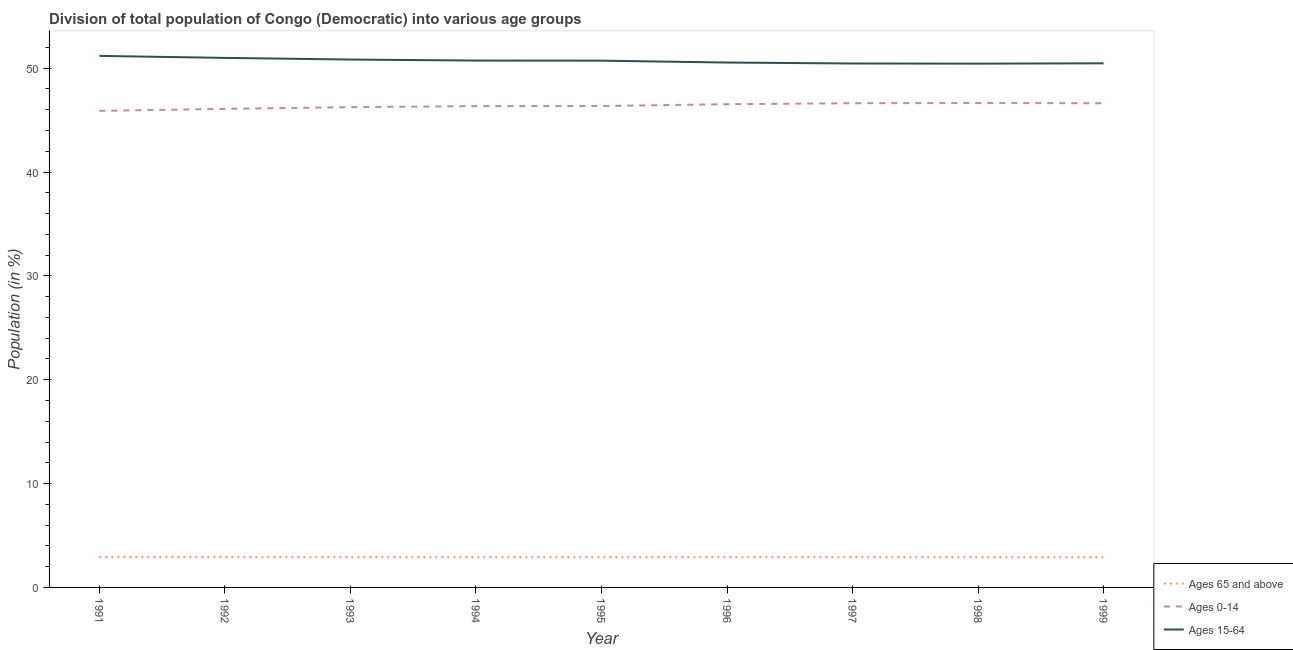How many different coloured lines are there?
Your answer should be very brief. 3. What is the percentage of population within the age-group 0-14 in 1996?
Your answer should be compact. 46.54. Across all years, what is the maximum percentage of population within the age-group of 65 and above?
Your response must be concise. 2.92. Across all years, what is the minimum percentage of population within the age-group 0-14?
Offer a terse response. 45.89. In which year was the percentage of population within the age-group 0-14 maximum?
Offer a terse response. 1998. What is the total percentage of population within the age-group of 65 and above in the graph?
Ensure brevity in your answer.  26.21. What is the difference between the percentage of population within the age-group 0-14 in 1991 and that in 1996?
Ensure brevity in your answer.  -0.64. What is the difference between the percentage of population within the age-group 15-64 in 1992 and the percentage of population within the age-group 0-14 in 1996?
Make the answer very short. 4.46. What is the average percentage of population within the age-group of 65 and above per year?
Keep it short and to the point. 2.91. In the year 1995, what is the difference between the percentage of population within the age-group 0-14 and percentage of population within the age-group of 65 and above?
Offer a terse response. 43.45. What is the ratio of the percentage of population within the age-group 0-14 in 1996 to that in 1998?
Provide a short and direct response. 1. Is the difference between the percentage of population within the age-group of 65 and above in 1991 and 1992 greater than the difference between the percentage of population within the age-group 0-14 in 1991 and 1992?
Your response must be concise. Yes. What is the difference between the highest and the second highest percentage of population within the age-group 15-64?
Your response must be concise. 0.19. What is the difference between the highest and the lowest percentage of population within the age-group of 65 and above?
Make the answer very short. 0.02. Does the percentage of population within the age-group 15-64 monotonically increase over the years?
Your answer should be compact. No. Is the percentage of population within the age-group 15-64 strictly less than the percentage of population within the age-group of 65 and above over the years?
Make the answer very short. No. How many years are there in the graph?
Ensure brevity in your answer.  9. What is the difference between two consecutive major ticks on the Y-axis?
Your answer should be compact. 10. Where does the legend appear in the graph?
Provide a short and direct response. Bottom right. How many legend labels are there?
Offer a very short reply. 3. What is the title of the graph?
Offer a terse response. Division of total population of Congo (Democratic) into various age groups
. What is the label or title of the Y-axis?
Offer a very short reply. Population (in %). What is the Population (in %) of Ages 65 and above in 1991?
Ensure brevity in your answer.  2.92. What is the Population (in %) in Ages 0-14 in 1991?
Ensure brevity in your answer.  45.89. What is the Population (in %) in Ages 15-64 in 1991?
Offer a terse response. 51.19. What is the Population (in %) of Ages 65 and above in 1992?
Offer a terse response. 2.92. What is the Population (in %) of Ages 0-14 in 1992?
Offer a very short reply. 46.09. What is the Population (in %) of Ages 15-64 in 1992?
Your response must be concise. 50.99. What is the Population (in %) of Ages 65 and above in 1993?
Offer a very short reply. 2.91. What is the Population (in %) in Ages 0-14 in 1993?
Your response must be concise. 46.25. What is the Population (in %) in Ages 15-64 in 1993?
Your answer should be compact. 50.84. What is the Population (in %) in Ages 65 and above in 1994?
Your answer should be very brief. 2.91. What is the Population (in %) of Ages 0-14 in 1994?
Your answer should be compact. 46.35. What is the Population (in %) in Ages 15-64 in 1994?
Your answer should be compact. 50.74. What is the Population (in %) of Ages 65 and above in 1995?
Offer a terse response. 2.91. What is the Population (in %) in Ages 0-14 in 1995?
Your answer should be very brief. 46.36. What is the Population (in %) in Ages 15-64 in 1995?
Offer a very short reply. 50.73. What is the Population (in %) in Ages 65 and above in 1996?
Provide a succinct answer. 2.92. What is the Population (in %) of Ages 0-14 in 1996?
Your answer should be very brief. 46.54. What is the Population (in %) in Ages 15-64 in 1996?
Offer a terse response. 50.55. What is the Population (in %) of Ages 65 and above in 1997?
Your response must be concise. 2.91. What is the Population (in %) in Ages 0-14 in 1997?
Give a very brief answer. 46.63. What is the Population (in %) of Ages 15-64 in 1997?
Provide a short and direct response. 50.46. What is the Population (in %) in Ages 65 and above in 1998?
Your response must be concise. 2.91. What is the Population (in %) of Ages 0-14 in 1998?
Provide a succinct answer. 46.65. What is the Population (in %) in Ages 15-64 in 1998?
Offer a terse response. 50.44. What is the Population (in %) of Ages 65 and above in 1999?
Offer a very short reply. 2.9. What is the Population (in %) in Ages 0-14 in 1999?
Give a very brief answer. 46.63. What is the Population (in %) of Ages 15-64 in 1999?
Provide a short and direct response. 50.47. Across all years, what is the maximum Population (in %) of Ages 65 and above?
Offer a very short reply. 2.92. Across all years, what is the maximum Population (in %) of Ages 0-14?
Make the answer very short. 46.65. Across all years, what is the maximum Population (in %) in Ages 15-64?
Provide a succinct answer. 51.19. Across all years, what is the minimum Population (in %) in Ages 65 and above?
Your response must be concise. 2.9. Across all years, what is the minimum Population (in %) in Ages 0-14?
Your answer should be compact. 45.89. Across all years, what is the minimum Population (in %) of Ages 15-64?
Keep it short and to the point. 50.44. What is the total Population (in %) of Ages 65 and above in the graph?
Your answer should be compact. 26.21. What is the total Population (in %) in Ages 0-14 in the graph?
Offer a terse response. 417.38. What is the total Population (in %) in Ages 15-64 in the graph?
Give a very brief answer. 456.4. What is the difference between the Population (in %) in Ages 65 and above in 1991 and that in 1992?
Offer a very short reply. 0. What is the difference between the Population (in %) in Ages 0-14 in 1991 and that in 1992?
Provide a short and direct response. -0.19. What is the difference between the Population (in %) of Ages 15-64 in 1991 and that in 1992?
Your answer should be compact. 0.19. What is the difference between the Population (in %) of Ages 65 and above in 1991 and that in 1993?
Your answer should be compact. 0. What is the difference between the Population (in %) in Ages 0-14 in 1991 and that in 1993?
Make the answer very short. -0.35. What is the difference between the Population (in %) of Ages 15-64 in 1991 and that in 1993?
Provide a succinct answer. 0.35. What is the difference between the Population (in %) of Ages 65 and above in 1991 and that in 1994?
Offer a very short reply. 0.01. What is the difference between the Population (in %) of Ages 0-14 in 1991 and that in 1994?
Make the answer very short. -0.46. What is the difference between the Population (in %) of Ages 15-64 in 1991 and that in 1994?
Provide a short and direct response. 0.45. What is the difference between the Population (in %) of Ages 65 and above in 1991 and that in 1995?
Ensure brevity in your answer.  0.01. What is the difference between the Population (in %) in Ages 0-14 in 1991 and that in 1995?
Provide a succinct answer. -0.47. What is the difference between the Population (in %) of Ages 15-64 in 1991 and that in 1995?
Keep it short and to the point. 0.46. What is the difference between the Population (in %) in Ages 65 and above in 1991 and that in 1996?
Ensure brevity in your answer.  0. What is the difference between the Population (in %) of Ages 0-14 in 1991 and that in 1996?
Keep it short and to the point. -0.64. What is the difference between the Population (in %) in Ages 15-64 in 1991 and that in 1996?
Provide a succinct answer. 0.64. What is the difference between the Population (in %) in Ages 65 and above in 1991 and that in 1997?
Give a very brief answer. 0. What is the difference between the Population (in %) of Ages 0-14 in 1991 and that in 1997?
Your answer should be compact. -0.73. What is the difference between the Population (in %) of Ages 15-64 in 1991 and that in 1997?
Provide a short and direct response. 0.73. What is the difference between the Population (in %) in Ages 65 and above in 1991 and that in 1998?
Your response must be concise. 0.01. What is the difference between the Population (in %) in Ages 0-14 in 1991 and that in 1998?
Provide a short and direct response. -0.75. What is the difference between the Population (in %) in Ages 15-64 in 1991 and that in 1998?
Provide a succinct answer. 0.75. What is the difference between the Population (in %) in Ages 65 and above in 1991 and that in 1999?
Your answer should be very brief. 0.02. What is the difference between the Population (in %) of Ages 0-14 in 1991 and that in 1999?
Provide a succinct answer. -0.73. What is the difference between the Population (in %) in Ages 15-64 in 1991 and that in 1999?
Offer a terse response. 0.71. What is the difference between the Population (in %) in Ages 65 and above in 1992 and that in 1993?
Ensure brevity in your answer.  0. What is the difference between the Population (in %) of Ages 0-14 in 1992 and that in 1993?
Provide a short and direct response. -0.16. What is the difference between the Population (in %) in Ages 15-64 in 1992 and that in 1993?
Offer a terse response. 0.16. What is the difference between the Population (in %) in Ages 65 and above in 1992 and that in 1994?
Your response must be concise. 0.01. What is the difference between the Population (in %) of Ages 0-14 in 1992 and that in 1994?
Your answer should be very brief. -0.26. What is the difference between the Population (in %) of Ages 15-64 in 1992 and that in 1994?
Give a very brief answer. 0.26. What is the difference between the Population (in %) in Ages 65 and above in 1992 and that in 1995?
Offer a very short reply. 0.01. What is the difference between the Population (in %) in Ages 0-14 in 1992 and that in 1995?
Your response must be concise. -0.27. What is the difference between the Population (in %) of Ages 15-64 in 1992 and that in 1995?
Ensure brevity in your answer.  0.27. What is the difference between the Population (in %) of Ages 65 and above in 1992 and that in 1996?
Your response must be concise. 0. What is the difference between the Population (in %) in Ages 0-14 in 1992 and that in 1996?
Make the answer very short. -0.45. What is the difference between the Population (in %) in Ages 15-64 in 1992 and that in 1996?
Your response must be concise. 0.45. What is the difference between the Population (in %) in Ages 65 and above in 1992 and that in 1997?
Your response must be concise. 0. What is the difference between the Population (in %) of Ages 0-14 in 1992 and that in 1997?
Provide a short and direct response. -0.54. What is the difference between the Population (in %) of Ages 15-64 in 1992 and that in 1997?
Your answer should be very brief. 0.54. What is the difference between the Population (in %) in Ages 65 and above in 1992 and that in 1998?
Make the answer very short. 0.01. What is the difference between the Population (in %) of Ages 0-14 in 1992 and that in 1998?
Make the answer very short. -0.56. What is the difference between the Population (in %) of Ages 15-64 in 1992 and that in 1998?
Your response must be concise. 0.55. What is the difference between the Population (in %) of Ages 65 and above in 1992 and that in 1999?
Make the answer very short. 0.02. What is the difference between the Population (in %) of Ages 0-14 in 1992 and that in 1999?
Your answer should be very brief. -0.54. What is the difference between the Population (in %) of Ages 15-64 in 1992 and that in 1999?
Provide a succinct answer. 0.52. What is the difference between the Population (in %) of Ages 65 and above in 1993 and that in 1994?
Your answer should be compact. 0. What is the difference between the Population (in %) of Ages 0-14 in 1993 and that in 1994?
Offer a terse response. -0.1. What is the difference between the Population (in %) of Ages 15-64 in 1993 and that in 1994?
Offer a terse response. 0.1. What is the difference between the Population (in %) of Ages 65 and above in 1993 and that in 1995?
Your answer should be very brief. 0. What is the difference between the Population (in %) in Ages 0-14 in 1993 and that in 1995?
Your answer should be very brief. -0.11. What is the difference between the Population (in %) of Ages 15-64 in 1993 and that in 1995?
Offer a terse response. 0.11. What is the difference between the Population (in %) in Ages 65 and above in 1993 and that in 1996?
Make the answer very short. -0. What is the difference between the Population (in %) of Ages 0-14 in 1993 and that in 1996?
Your answer should be compact. -0.29. What is the difference between the Population (in %) of Ages 15-64 in 1993 and that in 1996?
Your response must be concise. 0.29. What is the difference between the Population (in %) of Ages 65 and above in 1993 and that in 1997?
Ensure brevity in your answer.  -0. What is the difference between the Population (in %) in Ages 0-14 in 1993 and that in 1997?
Keep it short and to the point. -0.38. What is the difference between the Population (in %) in Ages 15-64 in 1993 and that in 1997?
Offer a very short reply. 0.38. What is the difference between the Population (in %) in Ages 65 and above in 1993 and that in 1998?
Your response must be concise. 0. What is the difference between the Population (in %) of Ages 0-14 in 1993 and that in 1998?
Offer a terse response. -0.4. What is the difference between the Population (in %) of Ages 15-64 in 1993 and that in 1998?
Offer a terse response. 0.4. What is the difference between the Population (in %) in Ages 65 and above in 1993 and that in 1999?
Give a very brief answer. 0.01. What is the difference between the Population (in %) in Ages 0-14 in 1993 and that in 1999?
Your response must be concise. -0.38. What is the difference between the Population (in %) of Ages 15-64 in 1993 and that in 1999?
Your response must be concise. 0.36. What is the difference between the Population (in %) in Ages 65 and above in 1994 and that in 1995?
Keep it short and to the point. -0. What is the difference between the Population (in %) of Ages 0-14 in 1994 and that in 1995?
Offer a very short reply. -0.01. What is the difference between the Population (in %) of Ages 15-64 in 1994 and that in 1995?
Keep it short and to the point. 0.01. What is the difference between the Population (in %) in Ages 65 and above in 1994 and that in 1996?
Keep it short and to the point. -0. What is the difference between the Population (in %) in Ages 0-14 in 1994 and that in 1996?
Your response must be concise. -0.18. What is the difference between the Population (in %) of Ages 15-64 in 1994 and that in 1996?
Your response must be concise. 0.19. What is the difference between the Population (in %) in Ages 65 and above in 1994 and that in 1997?
Give a very brief answer. -0. What is the difference between the Population (in %) in Ages 0-14 in 1994 and that in 1997?
Your answer should be very brief. -0.28. What is the difference between the Population (in %) in Ages 15-64 in 1994 and that in 1997?
Provide a short and direct response. 0.28. What is the difference between the Population (in %) in Ages 65 and above in 1994 and that in 1998?
Offer a terse response. 0. What is the difference between the Population (in %) of Ages 0-14 in 1994 and that in 1998?
Give a very brief answer. -0.3. What is the difference between the Population (in %) in Ages 15-64 in 1994 and that in 1998?
Ensure brevity in your answer.  0.3. What is the difference between the Population (in %) in Ages 65 and above in 1994 and that in 1999?
Provide a short and direct response. 0.01. What is the difference between the Population (in %) of Ages 0-14 in 1994 and that in 1999?
Keep it short and to the point. -0.28. What is the difference between the Population (in %) of Ages 15-64 in 1994 and that in 1999?
Your response must be concise. 0.26. What is the difference between the Population (in %) in Ages 65 and above in 1995 and that in 1996?
Ensure brevity in your answer.  -0. What is the difference between the Population (in %) in Ages 0-14 in 1995 and that in 1996?
Your response must be concise. -0.17. What is the difference between the Population (in %) of Ages 15-64 in 1995 and that in 1996?
Your answer should be compact. 0.18. What is the difference between the Population (in %) of Ages 65 and above in 1995 and that in 1997?
Keep it short and to the point. -0. What is the difference between the Population (in %) of Ages 0-14 in 1995 and that in 1997?
Offer a very short reply. -0.27. What is the difference between the Population (in %) in Ages 15-64 in 1995 and that in 1997?
Make the answer very short. 0.27. What is the difference between the Population (in %) of Ages 65 and above in 1995 and that in 1998?
Give a very brief answer. 0. What is the difference between the Population (in %) in Ages 0-14 in 1995 and that in 1998?
Provide a short and direct response. -0.29. What is the difference between the Population (in %) of Ages 15-64 in 1995 and that in 1998?
Offer a terse response. 0.29. What is the difference between the Population (in %) of Ages 65 and above in 1995 and that in 1999?
Provide a short and direct response. 0.01. What is the difference between the Population (in %) in Ages 0-14 in 1995 and that in 1999?
Your answer should be very brief. -0.27. What is the difference between the Population (in %) of Ages 15-64 in 1995 and that in 1999?
Your answer should be very brief. 0.25. What is the difference between the Population (in %) in Ages 65 and above in 1996 and that in 1997?
Offer a very short reply. 0. What is the difference between the Population (in %) of Ages 0-14 in 1996 and that in 1997?
Keep it short and to the point. -0.09. What is the difference between the Population (in %) of Ages 15-64 in 1996 and that in 1997?
Provide a short and direct response. 0.09. What is the difference between the Population (in %) of Ages 65 and above in 1996 and that in 1998?
Keep it short and to the point. 0.01. What is the difference between the Population (in %) in Ages 0-14 in 1996 and that in 1998?
Your answer should be compact. -0.11. What is the difference between the Population (in %) in Ages 15-64 in 1996 and that in 1998?
Ensure brevity in your answer.  0.11. What is the difference between the Population (in %) in Ages 65 and above in 1996 and that in 1999?
Offer a very short reply. 0.02. What is the difference between the Population (in %) of Ages 0-14 in 1996 and that in 1999?
Keep it short and to the point. -0.09. What is the difference between the Population (in %) in Ages 15-64 in 1996 and that in 1999?
Make the answer very short. 0.08. What is the difference between the Population (in %) of Ages 65 and above in 1997 and that in 1998?
Provide a succinct answer. 0.01. What is the difference between the Population (in %) in Ages 0-14 in 1997 and that in 1998?
Provide a short and direct response. -0.02. What is the difference between the Population (in %) in Ages 15-64 in 1997 and that in 1998?
Offer a terse response. 0.01. What is the difference between the Population (in %) in Ages 65 and above in 1997 and that in 1999?
Provide a succinct answer. 0.01. What is the difference between the Population (in %) of Ages 0-14 in 1997 and that in 1999?
Provide a short and direct response. 0. What is the difference between the Population (in %) of Ages 15-64 in 1997 and that in 1999?
Your answer should be very brief. -0.02. What is the difference between the Population (in %) in Ages 65 and above in 1998 and that in 1999?
Make the answer very short. 0.01. What is the difference between the Population (in %) in Ages 0-14 in 1998 and that in 1999?
Make the answer very short. 0.02. What is the difference between the Population (in %) in Ages 15-64 in 1998 and that in 1999?
Keep it short and to the point. -0.03. What is the difference between the Population (in %) of Ages 65 and above in 1991 and the Population (in %) of Ages 0-14 in 1992?
Provide a short and direct response. -43.17. What is the difference between the Population (in %) of Ages 65 and above in 1991 and the Population (in %) of Ages 15-64 in 1992?
Keep it short and to the point. -48.08. What is the difference between the Population (in %) in Ages 0-14 in 1991 and the Population (in %) in Ages 15-64 in 1992?
Give a very brief answer. -5.1. What is the difference between the Population (in %) in Ages 65 and above in 1991 and the Population (in %) in Ages 0-14 in 1993?
Your answer should be very brief. -43.33. What is the difference between the Population (in %) in Ages 65 and above in 1991 and the Population (in %) in Ages 15-64 in 1993?
Offer a very short reply. -47.92. What is the difference between the Population (in %) in Ages 0-14 in 1991 and the Population (in %) in Ages 15-64 in 1993?
Provide a short and direct response. -4.94. What is the difference between the Population (in %) in Ages 65 and above in 1991 and the Population (in %) in Ages 0-14 in 1994?
Make the answer very short. -43.43. What is the difference between the Population (in %) of Ages 65 and above in 1991 and the Population (in %) of Ages 15-64 in 1994?
Offer a very short reply. -47.82. What is the difference between the Population (in %) in Ages 0-14 in 1991 and the Population (in %) in Ages 15-64 in 1994?
Your answer should be very brief. -4.84. What is the difference between the Population (in %) in Ages 65 and above in 1991 and the Population (in %) in Ages 0-14 in 1995?
Your response must be concise. -43.44. What is the difference between the Population (in %) in Ages 65 and above in 1991 and the Population (in %) in Ages 15-64 in 1995?
Offer a very short reply. -47.81. What is the difference between the Population (in %) in Ages 0-14 in 1991 and the Population (in %) in Ages 15-64 in 1995?
Provide a succinct answer. -4.83. What is the difference between the Population (in %) in Ages 65 and above in 1991 and the Population (in %) in Ages 0-14 in 1996?
Provide a succinct answer. -43.62. What is the difference between the Population (in %) of Ages 65 and above in 1991 and the Population (in %) of Ages 15-64 in 1996?
Provide a succinct answer. -47.63. What is the difference between the Population (in %) of Ages 0-14 in 1991 and the Population (in %) of Ages 15-64 in 1996?
Your answer should be very brief. -4.65. What is the difference between the Population (in %) in Ages 65 and above in 1991 and the Population (in %) in Ages 0-14 in 1997?
Offer a terse response. -43.71. What is the difference between the Population (in %) of Ages 65 and above in 1991 and the Population (in %) of Ages 15-64 in 1997?
Offer a very short reply. -47.54. What is the difference between the Population (in %) in Ages 0-14 in 1991 and the Population (in %) in Ages 15-64 in 1997?
Your answer should be very brief. -4.56. What is the difference between the Population (in %) of Ages 65 and above in 1991 and the Population (in %) of Ages 0-14 in 1998?
Make the answer very short. -43.73. What is the difference between the Population (in %) in Ages 65 and above in 1991 and the Population (in %) in Ages 15-64 in 1998?
Keep it short and to the point. -47.52. What is the difference between the Population (in %) of Ages 0-14 in 1991 and the Population (in %) of Ages 15-64 in 1998?
Make the answer very short. -4.55. What is the difference between the Population (in %) of Ages 65 and above in 1991 and the Population (in %) of Ages 0-14 in 1999?
Make the answer very short. -43.71. What is the difference between the Population (in %) in Ages 65 and above in 1991 and the Population (in %) in Ages 15-64 in 1999?
Offer a terse response. -47.55. What is the difference between the Population (in %) in Ages 0-14 in 1991 and the Population (in %) in Ages 15-64 in 1999?
Your answer should be very brief. -4.58. What is the difference between the Population (in %) in Ages 65 and above in 1992 and the Population (in %) in Ages 0-14 in 1993?
Offer a terse response. -43.33. What is the difference between the Population (in %) in Ages 65 and above in 1992 and the Population (in %) in Ages 15-64 in 1993?
Give a very brief answer. -47.92. What is the difference between the Population (in %) in Ages 0-14 in 1992 and the Population (in %) in Ages 15-64 in 1993?
Your answer should be very brief. -4.75. What is the difference between the Population (in %) of Ages 65 and above in 1992 and the Population (in %) of Ages 0-14 in 1994?
Your answer should be compact. -43.43. What is the difference between the Population (in %) of Ages 65 and above in 1992 and the Population (in %) of Ages 15-64 in 1994?
Make the answer very short. -47.82. What is the difference between the Population (in %) of Ages 0-14 in 1992 and the Population (in %) of Ages 15-64 in 1994?
Your answer should be compact. -4.65. What is the difference between the Population (in %) of Ages 65 and above in 1992 and the Population (in %) of Ages 0-14 in 1995?
Offer a terse response. -43.44. What is the difference between the Population (in %) of Ages 65 and above in 1992 and the Population (in %) of Ages 15-64 in 1995?
Offer a terse response. -47.81. What is the difference between the Population (in %) in Ages 0-14 in 1992 and the Population (in %) in Ages 15-64 in 1995?
Provide a short and direct response. -4.64. What is the difference between the Population (in %) of Ages 65 and above in 1992 and the Population (in %) of Ages 0-14 in 1996?
Offer a terse response. -43.62. What is the difference between the Population (in %) in Ages 65 and above in 1992 and the Population (in %) in Ages 15-64 in 1996?
Your response must be concise. -47.63. What is the difference between the Population (in %) in Ages 0-14 in 1992 and the Population (in %) in Ages 15-64 in 1996?
Provide a short and direct response. -4.46. What is the difference between the Population (in %) of Ages 65 and above in 1992 and the Population (in %) of Ages 0-14 in 1997?
Give a very brief answer. -43.71. What is the difference between the Population (in %) in Ages 65 and above in 1992 and the Population (in %) in Ages 15-64 in 1997?
Provide a short and direct response. -47.54. What is the difference between the Population (in %) of Ages 0-14 in 1992 and the Population (in %) of Ages 15-64 in 1997?
Provide a succinct answer. -4.37. What is the difference between the Population (in %) in Ages 65 and above in 1992 and the Population (in %) in Ages 0-14 in 1998?
Your answer should be compact. -43.73. What is the difference between the Population (in %) of Ages 65 and above in 1992 and the Population (in %) of Ages 15-64 in 1998?
Offer a very short reply. -47.52. What is the difference between the Population (in %) in Ages 0-14 in 1992 and the Population (in %) in Ages 15-64 in 1998?
Give a very brief answer. -4.35. What is the difference between the Population (in %) in Ages 65 and above in 1992 and the Population (in %) in Ages 0-14 in 1999?
Offer a terse response. -43.71. What is the difference between the Population (in %) in Ages 65 and above in 1992 and the Population (in %) in Ages 15-64 in 1999?
Keep it short and to the point. -47.56. What is the difference between the Population (in %) of Ages 0-14 in 1992 and the Population (in %) of Ages 15-64 in 1999?
Your answer should be very brief. -4.39. What is the difference between the Population (in %) in Ages 65 and above in 1993 and the Population (in %) in Ages 0-14 in 1994?
Offer a very short reply. -43.44. What is the difference between the Population (in %) of Ages 65 and above in 1993 and the Population (in %) of Ages 15-64 in 1994?
Ensure brevity in your answer.  -47.82. What is the difference between the Population (in %) of Ages 0-14 in 1993 and the Population (in %) of Ages 15-64 in 1994?
Give a very brief answer. -4.49. What is the difference between the Population (in %) in Ages 65 and above in 1993 and the Population (in %) in Ages 0-14 in 1995?
Provide a succinct answer. -43.45. What is the difference between the Population (in %) in Ages 65 and above in 1993 and the Population (in %) in Ages 15-64 in 1995?
Ensure brevity in your answer.  -47.81. What is the difference between the Population (in %) of Ages 0-14 in 1993 and the Population (in %) of Ages 15-64 in 1995?
Your response must be concise. -4.48. What is the difference between the Population (in %) of Ages 65 and above in 1993 and the Population (in %) of Ages 0-14 in 1996?
Offer a very short reply. -43.62. What is the difference between the Population (in %) in Ages 65 and above in 1993 and the Population (in %) in Ages 15-64 in 1996?
Provide a succinct answer. -47.63. What is the difference between the Population (in %) in Ages 0-14 in 1993 and the Population (in %) in Ages 15-64 in 1996?
Offer a very short reply. -4.3. What is the difference between the Population (in %) of Ages 65 and above in 1993 and the Population (in %) of Ages 0-14 in 1997?
Your response must be concise. -43.71. What is the difference between the Population (in %) in Ages 65 and above in 1993 and the Population (in %) in Ages 15-64 in 1997?
Your response must be concise. -47.54. What is the difference between the Population (in %) in Ages 0-14 in 1993 and the Population (in %) in Ages 15-64 in 1997?
Give a very brief answer. -4.21. What is the difference between the Population (in %) of Ages 65 and above in 1993 and the Population (in %) of Ages 0-14 in 1998?
Offer a terse response. -43.73. What is the difference between the Population (in %) of Ages 65 and above in 1993 and the Population (in %) of Ages 15-64 in 1998?
Make the answer very short. -47.53. What is the difference between the Population (in %) of Ages 0-14 in 1993 and the Population (in %) of Ages 15-64 in 1998?
Give a very brief answer. -4.19. What is the difference between the Population (in %) of Ages 65 and above in 1993 and the Population (in %) of Ages 0-14 in 1999?
Offer a very short reply. -43.71. What is the difference between the Population (in %) in Ages 65 and above in 1993 and the Population (in %) in Ages 15-64 in 1999?
Offer a terse response. -47.56. What is the difference between the Population (in %) of Ages 0-14 in 1993 and the Population (in %) of Ages 15-64 in 1999?
Provide a short and direct response. -4.22. What is the difference between the Population (in %) of Ages 65 and above in 1994 and the Population (in %) of Ages 0-14 in 1995?
Your answer should be compact. -43.45. What is the difference between the Population (in %) of Ages 65 and above in 1994 and the Population (in %) of Ages 15-64 in 1995?
Ensure brevity in your answer.  -47.82. What is the difference between the Population (in %) of Ages 0-14 in 1994 and the Population (in %) of Ages 15-64 in 1995?
Give a very brief answer. -4.38. What is the difference between the Population (in %) in Ages 65 and above in 1994 and the Population (in %) in Ages 0-14 in 1996?
Keep it short and to the point. -43.62. What is the difference between the Population (in %) of Ages 65 and above in 1994 and the Population (in %) of Ages 15-64 in 1996?
Provide a succinct answer. -47.64. What is the difference between the Population (in %) in Ages 0-14 in 1994 and the Population (in %) in Ages 15-64 in 1996?
Your answer should be very brief. -4.2. What is the difference between the Population (in %) in Ages 65 and above in 1994 and the Population (in %) in Ages 0-14 in 1997?
Provide a succinct answer. -43.72. What is the difference between the Population (in %) in Ages 65 and above in 1994 and the Population (in %) in Ages 15-64 in 1997?
Offer a very short reply. -47.55. What is the difference between the Population (in %) in Ages 0-14 in 1994 and the Population (in %) in Ages 15-64 in 1997?
Your answer should be compact. -4.11. What is the difference between the Population (in %) in Ages 65 and above in 1994 and the Population (in %) in Ages 0-14 in 1998?
Provide a succinct answer. -43.74. What is the difference between the Population (in %) of Ages 65 and above in 1994 and the Population (in %) of Ages 15-64 in 1998?
Offer a terse response. -47.53. What is the difference between the Population (in %) in Ages 0-14 in 1994 and the Population (in %) in Ages 15-64 in 1998?
Your response must be concise. -4.09. What is the difference between the Population (in %) in Ages 65 and above in 1994 and the Population (in %) in Ages 0-14 in 1999?
Your answer should be very brief. -43.71. What is the difference between the Population (in %) of Ages 65 and above in 1994 and the Population (in %) of Ages 15-64 in 1999?
Your answer should be compact. -47.56. What is the difference between the Population (in %) of Ages 0-14 in 1994 and the Population (in %) of Ages 15-64 in 1999?
Offer a very short reply. -4.12. What is the difference between the Population (in %) of Ages 65 and above in 1995 and the Population (in %) of Ages 0-14 in 1996?
Make the answer very short. -43.62. What is the difference between the Population (in %) in Ages 65 and above in 1995 and the Population (in %) in Ages 15-64 in 1996?
Your response must be concise. -47.64. What is the difference between the Population (in %) in Ages 0-14 in 1995 and the Population (in %) in Ages 15-64 in 1996?
Give a very brief answer. -4.19. What is the difference between the Population (in %) in Ages 65 and above in 1995 and the Population (in %) in Ages 0-14 in 1997?
Provide a short and direct response. -43.72. What is the difference between the Population (in %) of Ages 65 and above in 1995 and the Population (in %) of Ages 15-64 in 1997?
Your answer should be compact. -47.54. What is the difference between the Population (in %) of Ages 0-14 in 1995 and the Population (in %) of Ages 15-64 in 1997?
Provide a succinct answer. -4.1. What is the difference between the Population (in %) in Ages 65 and above in 1995 and the Population (in %) in Ages 0-14 in 1998?
Your response must be concise. -43.74. What is the difference between the Population (in %) in Ages 65 and above in 1995 and the Population (in %) in Ages 15-64 in 1998?
Give a very brief answer. -47.53. What is the difference between the Population (in %) of Ages 0-14 in 1995 and the Population (in %) of Ages 15-64 in 1998?
Give a very brief answer. -4.08. What is the difference between the Population (in %) in Ages 65 and above in 1995 and the Population (in %) in Ages 0-14 in 1999?
Make the answer very short. -43.71. What is the difference between the Population (in %) of Ages 65 and above in 1995 and the Population (in %) of Ages 15-64 in 1999?
Ensure brevity in your answer.  -47.56. What is the difference between the Population (in %) in Ages 0-14 in 1995 and the Population (in %) in Ages 15-64 in 1999?
Keep it short and to the point. -4.11. What is the difference between the Population (in %) of Ages 65 and above in 1996 and the Population (in %) of Ages 0-14 in 1997?
Your answer should be very brief. -43.71. What is the difference between the Population (in %) of Ages 65 and above in 1996 and the Population (in %) of Ages 15-64 in 1997?
Ensure brevity in your answer.  -47.54. What is the difference between the Population (in %) in Ages 0-14 in 1996 and the Population (in %) in Ages 15-64 in 1997?
Your answer should be very brief. -3.92. What is the difference between the Population (in %) of Ages 65 and above in 1996 and the Population (in %) of Ages 0-14 in 1998?
Your response must be concise. -43.73. What is the difference between the Population (in %) of Ages 65 and above in 1996 and the Population (in %) of Ages 15-64 in 1998?
Give a very brief answer. -47.53. What is the difference between the Population (in %) of Ages 0-14 in 1996 and the Population (in %) of Ages 15-64 in 1998?
Your response must be concise. -3.91. What is the difference between the Population (in %) in Ages 65 and above in 1996 and the Population (in %) in Ages 0-14 in 1999?
Offer a very short reply. -43.71. What is the difference between the Population (in %) of Ages 65 and above in 1996 and the Population (in %) of Ages 15-64 in 1999?
Keep it short and to the point. -47.56. What is the difference between the Population (in %) in Ages 0-14 in 1996 and the Population (in %) in Ages 15-64 in 1999?
Offer a very short reply. -3.94. What is the difference between the Population (in %) in Ages 65 and above in 1997 and the Population (in %) in Ages 0-14 in 1998?
Your response must be concise. -43.73. What is the difference between the Population (in %) of Ages 65 and above in 1997 and the Population (in %) of Ages 15-64 in 1998?
Give a very brief answer. -47.53. What is the difference between the Population (in %) of Ages 0-14 in 1997 and the Population (in %) of Ages 15-64 in 1998?
Ensure brevity in your answer.  -3.81. What is the difference between the Population (in %) in Ages 65 and above in 1997 and the Population (in %) in Ages 0-14 in 1999?
Keep it short and to the point. -43.71. What is the difference between the Population (in %) in Ages 65 and above in 1997 and the Population (in %) in Ages 15-64 in 1999?
Offer a very short reply. -47.56. What is the difference between the Population (in %) of Ages 0-14 in 1997 and the Population (in %) of Ages 15-64 in 1999?
Offer a very short reply. -3.84. What is the difference between the Population (in %) of Ages 65 and above in 1998 and the Population (in %) of Ages 0-14 in 1999?
Keep it short and to the point. -43.72. What is the difference between the Population (in %) in Ages 65 and above in 1998 and the Population (in %) in Ages 15-64 in 1999?
Make the answer very short. -47.56. What is the difference between the Population (in %) of Ages 0-14 in 1998 and the Population (in %) of Ages 15-64 in 1999?
Offer a terse response. -3.83. What is the average Population (in %) of Ages 65 and above per year?
Give a very brief answer. 2.91. What is the average Population (in %) in Ages 0-14 per year?
Keep it short and to the point. 46.38. What is the average Population (in %) of Ages 15-64 per year?
Provide a succinct answer. 50.71. In the year 1991, what is the difference between the Population (in %) of Ages 65 and above and Population (in %) of Ages 0-14?
Offer a terse response. -42.98. In the year 1991, what is the difference between the Population (in %) in Ages 65 and above and Population (in %) in Ages 15-64?
Offer a very short reply. -48.27. In the year 1991, what is the difference between the Population (in %) of Ages 0-14 and Population (in %) of Ages 15-64?
Offer a very short reply. -5.29. In the year 1992, what is the difference between the Population (in %) of Ages 65 and above and Population (in %) of Ages 0-14?
Offer a very short reply. -43.17. In the year 1992, what is the difference between the Population (in %) in Ages 65 and above and Population (in %) in Ages 15-64?
Provide a short and direct response. -48.08. In the year 1992, what is the difference between the Population (in %) in Ages 0-14 and Population (in %) in Ages 15-64?
Keep it short and to the point. -4.91. In the year 1993, what is the difference between the Population (in %) of Ages 65 and above and Population (in %) of Ages 0-14?
Provide a succinct answer. -43.33. In the year 1993, what is the difference between the Population (in %) of Ages 65 and above and Population (in %) of Ages 15-64?
Offer a very short reply. -47.92. In the year 1993, what is the difference between the Population (in %) in Ages 0-14 and Population (in %) in Ages 15-64?
Your answer should be compact. -4.59. In the year 1994, what is the difference between the Population (in %) of Ages 65 and above and Population (in %) of Ages 0-14?
Keep it short and to the point. -43.44. In the year 1994, what is the difference between the Population (in %) of Ages 65 and above and Population (in %) of Ages 15-64?
Provide a short and direct response. -47.83. In the year 1994, what is the difference between the Population (in %) of Ages 0-14 and Population (in %) of Ages 15-64?
Give a very brief answer. -4.39. In the year 1995, what is the difference between the Population (in %) in Ages 65 and above and Population (in %) in Ages 0-14?
Offer a very short reply. -43.45. In the year 1995, what is the difference between the Population (in %) of Ages 65 and above and Population (in %) of Ages 15-64?
Provide a short and direct response. -47.82. In the year 1995, what is the difference between the Population (in %) of Ages 0-14 and Population (in %) of Ages 15-64?
Keep it short and to the point. -4.37. In the year 1996, what is the difference between the Population (in %) in Ages 65 and above and Population (in %) in Ages 0-14?
Offer a terse response. -43.62. In the year 1996, what is the difference between the Population (in %) of Ages 65 and above and Population (in %) of Ages 15-64?
Your answer should be very brief. -47.63. In the year 1996, what is the difference between the Population (in %) of Ages 0-14 and Population (in %) of Ages 15-64?
Ensure brevity in your answer.  -4.01. In the year 1997, what is the difference between the Population (in %) in Ages 65 and above and Population (in %) in Ages 0-14?
Give a very brief answer. -43.71. In the year 1997, what is the difference between the Population (in %) in Ages 65 and above and Population (in %) in Ages 15-64?
Make the answer very short. -47.54. In the year 1997, what is the difference between the Population (in %) of Ages 0-14 and Population (in %) of Ages 15-64?
Make the answer very short. -3.83. In the year 1998, what is the difference between the Population (in %) of Ages 65 and above and Population (in %) of Ages 0-14?
Your answer should be very brief. -43.74. In the year 1998, what is the difference between the Population (in %) in Ages 65 and above and Population (in %) in Ages 15-64?
Offer a very short reply. -47.53. In the year 1998, what is the difference between the Population (in %) in Ages 0-14 and Population (in %) in Ages 15-64?
Your answer should be compact. -3.79. In the year 1999, what is the difference between the Population (in %) of Ages 65 and above and Population (in %) of Ages 0-14?
Offer a terse response. -43.73. In the year 1999, what is the difference between the Population (in %) in Ages 65 and above and Population (in %) in Ages 15-64?
Your answer should be very brief. -47.57. In the year 1999, what is the difference between the Population (in %) of Ages 0-14 and Population (in %) of Ages 15-64?
Make the answer very short. -3.85. What is the ratio of the Population (in %) of Ages 65 and above in 1991 to that in 1993?
Your response must be concise. 1. What is the ratio of the Population (in %) of Ages 0-14 in 1991 to that in 1993?
Provide a short and direct response. 0.99. What is the ratio of the Population (in %) in Ages 15-64 in 1991 to that in 1994?
Provide a short and direct response. 1.01. What is the ratio of the Population (in %) of Ages 65 and above in 1991 to that in 1995?
Ensure brevity in your answer.  1. What is the ratio of the Population (in %) of Ages 15-64 in 1991 to that in 1995?
Give a very brief answer. 1.01. What is the ratio of the Population (in %) in Ages 65 and above in 1991 to that in 1996?
Give a very brief answer. 1. What is the ratio of the Population (in %) of Ages 0-14 in 1991 to that in 1996?
Your answer should be compact. 0.99. What is the ratio of the Population (in %) in Ages 15-64 in 1991 to that in 1996?
Offer a terse response. 1.01. What is the ratio of the Population (in %) of Ages 0-14 in 1991 to that in 1997?
Give a very brief answer. 0.98. What is the ratio of the Population (in %) of Ages 15-64 in 1991 to that in 1997?
Your answer should be very brief. 1.01. What is the ratio of the Population (in %) in Ages 65 and above in 1991 to that in 1998?
Your answer should be compact. 1. What is the ratio of the Population (in %) in Ages 0-14 in 1991 to that in 1998?
Ensure brevity in your answer.  0.98. What is the ratio of the Population (in %) in Ages 15-64 in 1991 to that in 1998?
Offer a terse response. 1.01. What is the ratio of the Population (in %) of Ages 65 and above in 1991 to that in 1999?
Offer a very short reply. 1.01. What is the ratio of the Population (in %) of Ages 0-14 in 1991 to that in 1999?
Your response must be concise. 0.98. What is the ratio of the Population (in %) of Ages 15-64 in 1991 to that in 1999?
Offer a very short reply. 1.01. What is the ratio of the Population (in %) in Ages 0-14 in 1992 to that in 1993?
Offer a terse response. 1. What is the ratio of the Population (in %) of Ages 15-64 in 1992 to that in 1993?
Your answer should be very brief. 1. What is the ratio of the Population (in %) in Ages 0-14 in 1992 to that in 1994?
Offer a very short reply. 0.99. What is the ratio of the Population (in %) in Ages 15-64 in 1992 to that in 1994?
Your answer should be compact. 1.01. What is the ratio of the Population (in %) in Ages 65 and above in 1992 to that in 1995?
Your answer should be compact. 1. What is the ratio of the Population (in %) in Ages 15-64 in 1992 to that in 1995?
Make the answer very short. 1.01. What is the ratio of the Population (in %) of Ages 65 and above in 1992 to that in 1996?
Provide a short and direct response. 1. What is the ratio of the Population (in %) of Ages 15-64 in 1992 to that in 1996?
Your answer should be very brief. 1.01. What is the ratio of the Population (in %) of Ages 0-14 in 1992 to that in 1997?
Offer a very short reply. 0.99. What is the ratio of the Population (in %) of Ages 15-64 in 1992 to that in 1997?
Offer a very short reply. 1.01. What is the ratio of the Population (in %) in Ages 65 and above in 1992 to that in 1998?
Give a very brief answer. 1. What is the ratio of the Population (in %) of Ages 15-64 in 1992 to that in 1998?
Keep it short and to the point. 1.01. What is the ratio of the Population (in %) in Ages 65 and above in 1992 to that in 1999?
Give a very brief answer. 1.01. What is the ratio of the Population (in %) of Ages 15-64 in 1992 to that in 1999?
Keep it short and to the point. 1.01. What is the ratio of the Population (in %) of Ages 65 and above in 1993 to that in 1994?
Provide a short and direct response. 1. What is the ratio of the Population (in %) in Ages 0-14 in 1993 to that in 1994?
Make the answer very short. 1. What is the ratio of the Population (in %) in Ages 0-14 in 1993 to that in 1995?
Offer a terse response. 1. What is the ratio of the Population (in %) of Ages 15-64 in 1993 to that in 1995?
Your response must be concise. 1. What is the ratio of the Population (in %) in Ages 0-14 in 1993 to that in 1996?
Ensure brevity in your answer.  0.99. What is the ratio of the Population (in %) in Ages 65 and above in 1993 to that in 1997?
Keep it short and to the point. 1. What is the ratio of the Population (in %) of Ages 0-14 in 1993 to that in 1997?
Provide a succinct answer. 0.99. What is the ratio of the Population (in %) in Ages 15-64 in 1993 to that in 1997?
Your answer should be very brief. 1.01. What is the ratio of the Population (in %) of Ages 65 and above in 1993 to that in 1998?
Give a very brief answer. 1. What is the ratio of the Population (in %) of Ages 0-14 in 1993 to that in 1998?
Ensure brevity in your answer.  0.99. What is the ratio of the Population (in %) in Ages 65 and above in 1993 to that in 1999?
Keep it short and to the point. 1. What is the ratio of the Population (in %) in Ages 15-64 in 1993 to that in 1999?
Make the answer very short. 1.01. What is the ratio of the Population (in %) of Ages 65 and above in 1994 to that in 1995?
Your response must be concise. 1. What is the ratio of the Population (in %) in Ages 0-14 in 1994 to that in 1995?
Give a very brief answer. 1. What is the ratio of the Population (in %) in Ages 15-64 in 1994 to that in 1995?
Keep it short and to the point. 1. What is the ratio of the Population (in %) in Ages 65 and above in 1994 to that in 1996?
Your answer should be compact. 1. What is the ratio of the Population (in %) of Ages 0-14 in 1994 to that in 1996?
Your answer should be very brief. 1. What is the ratio of the Population (in %) in Ages 0-14 in 1994 to that in 1997?
Your answer should be compact. 0.99. What is the ratio of the Population (in %) in Ages 15-64 in 1994 to that in 1997?
Keep it short and to the point. 1.01. What is the ratio of the Population (in %) in Ages 15-64 in 1994 to that in 1998?
Ensure brevity in your answer.  1.01. What is the ratio of the Population (in %) in Ages 15-64 in 1994 to that in 1999?
Provide a short and direct response. 1.01. What is the ratio of the Population (in %) of Ages 15-64 in 1995 to that in 1996?
Offer a terse response. 1. What is the ratio of the Population (in %) in Ages 65 and above in 1995 to that in 1997?
Provide a short and direct response. 1. What is the ratio of the Population (in %) of Ages 0-14 in 1995 to that in 1997?
Provide a short and direct response. 0.99. What is the ratio of the Population (in %) of Ages 15-64 in 1995 to that in 1997?
Give a very brief answer. 1.01. What is the ratio of the Population (in %) of Ages 0-14 in 1995 to that in 1998?
Make the answer very short. 0.99. What is the ratio of the Population (in %) in Ages 65 and above in 1995 to that in 1999?
Make the answer very short. 1. What is the ratio of the Population (in %) in Ages 0-14 in 1995 to that in 1999?
Provide a short and direct response. 0.99. What is the ratio of the Population (in %) of Ages 15-64 in 1996 to that in 1998?
Your answer should be very brief. 1. What is the ratio of the Population (in %) in Ages 65 and above in 1996 to that in 1999?
Your answer should be very brief. 1.01. What is the ratio of the Population (in %) in Ages 15-64 in 1996 to that in 1999?
Your answer should be compact. 1. What is the ratio of the Population (in %) in Ages 65 and above in 1997 to that in 1998?
Offer a terse response. 1. What is the ratio of the Population (in %) of Ages 0-14 in 1997 to that in 1999?
Provide a short and direct response. 1. What is the ratio of the Population (in %) of Ages 65 and above in 1998 to that in 1999?
Keep it short and to the point. 1. What is the difference between the highest and the second highest Population (in %) in Ages 65 and above?
Give a very brief answer. 0. What is the difference between the highest and the second highest Population (in %) of Ages 0-14?
Ensure brevity in your answer.  0.02. What is the difference between the highest and the second highest Population (in %) in Ages 15-64?
Provide a succinct answer. 0.19. What is the difference between the highest and the lowest Population (in %) in Ages 65 and above?
Provide a short and direct response. 0.02. What is the difference between the highest and the lowest Population (in %) in Ages 0-14?
Make the answer very short. 0.75. What is the difference between the highest and the lowest Population (in %) of Ages 15-64?
Keep it short and to the point. 0.75. 